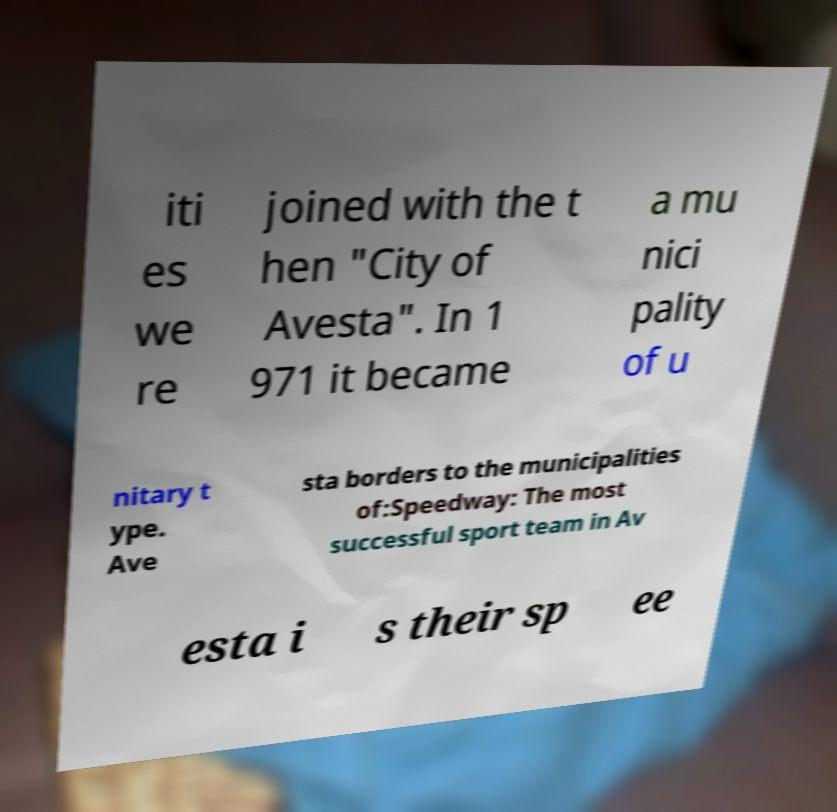Please read and relay the text visible in this image. What does it say? iti es we re joined with the t hen "City of Avesta". In 1 971 it became a mu nici pality of u nitary t ype. Ave sta borders to the municipalities of:Speedway: The most successful sport team in Av esta i s their sp ee 